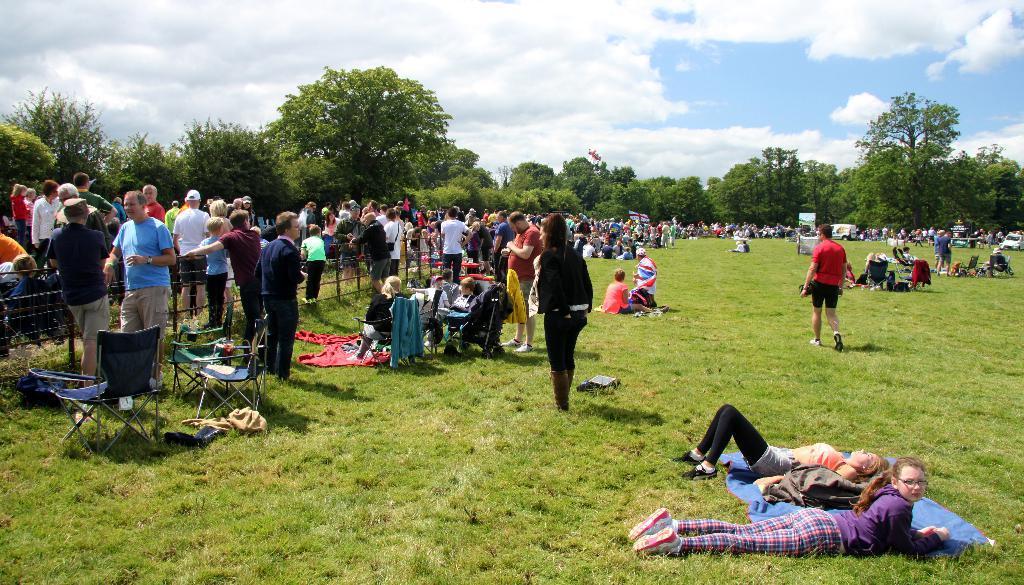Please provide a concise description of this image. There is a huge crowd gathered in an open area, the land is covered with plenty of grass and a few of them are lying on the grass and some of them are sitting on the grass and some other people are standing beside the fencing and few people are sitting on the chairs, around the land there are plenty of trees. On the right side there is a vehicle. 